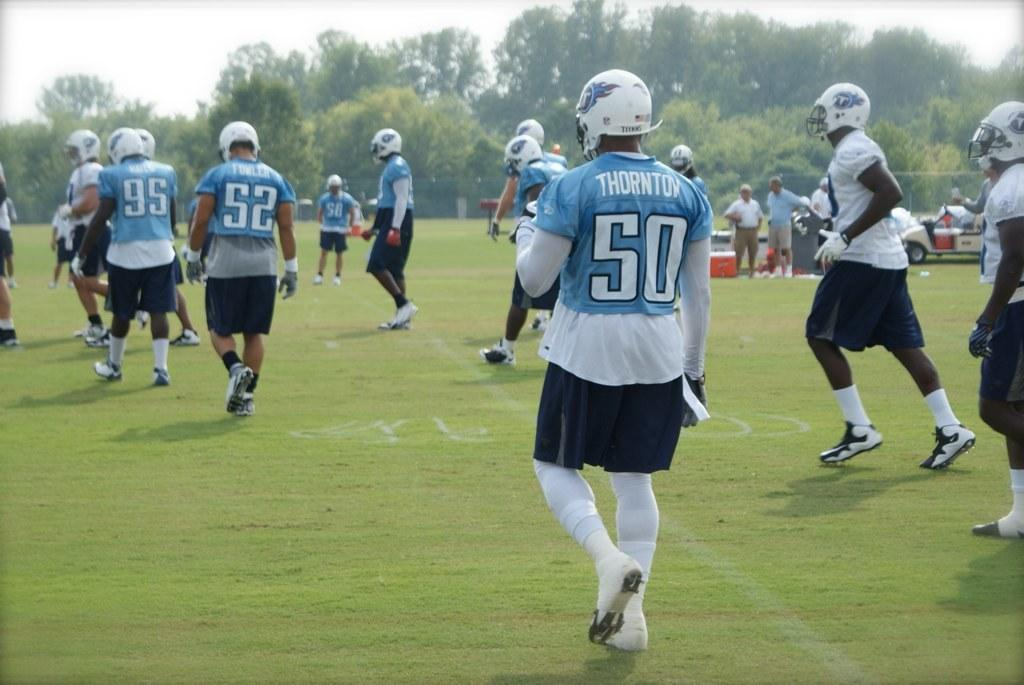What are the persons in the image doing? The persons in the image are walking on the ground. Can you describe the background of the image? In the background of the image, there are persons standing, objects, a vehicle, trees, and the sky. How many elements can be seen in the background of the image? There are six elements visible in the background: persons standing, objects, a vehicle, trees, and the sky. What type of knot is being tied by the person in the image? There is no person tying a knot in the image; the persons are walking and standing. What street can be seen in the image? There is no street visible in the image; the persons are walking on the ground, and the background contains objects, a vehicle, trees, and the sky. 